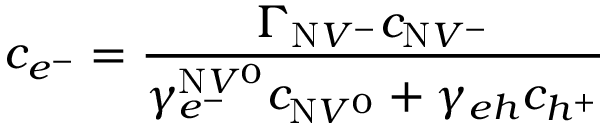<formula> <loc_0><loc_0><loc_500><loc_500>c _ { e ^ { - } } = \frac { \Gamma _ { N V ^ { - } } c _ { N V ^ { - } } } { \gamma _ { e ^ { - } } ^ { N V ^ { 0 } } c _ { N V ^ { 0 } } + \gamma _ { e h } c _ { h ^ { + } } }</formula> 